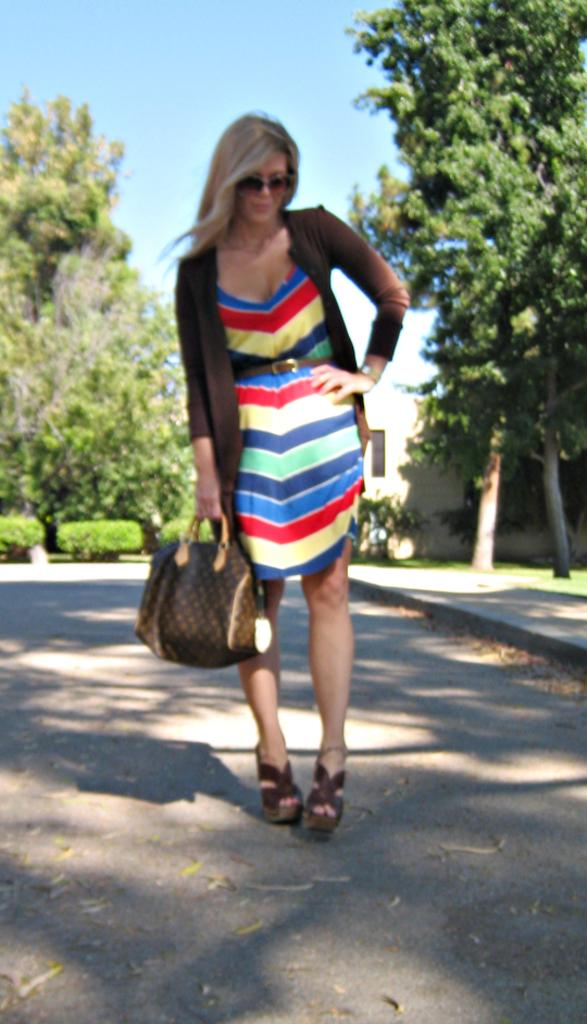What is the woman doing in the image? She is standing in the image. What is she holding in her hand? She is holding a handbag. What accessory is she wearing on her face? She is wearing spectacles. What accessory is she wearing on her wrist? She is wearing a watch. What type of clothing is she wearing on her upper body? She is wearing a colorful jacket. What can be seen in the background of the image? There is sky and trees visible in the background. What type of clover is she holding in her pocket in the image? There is no clover present in the image, and she is not holding anything in her pocket. 